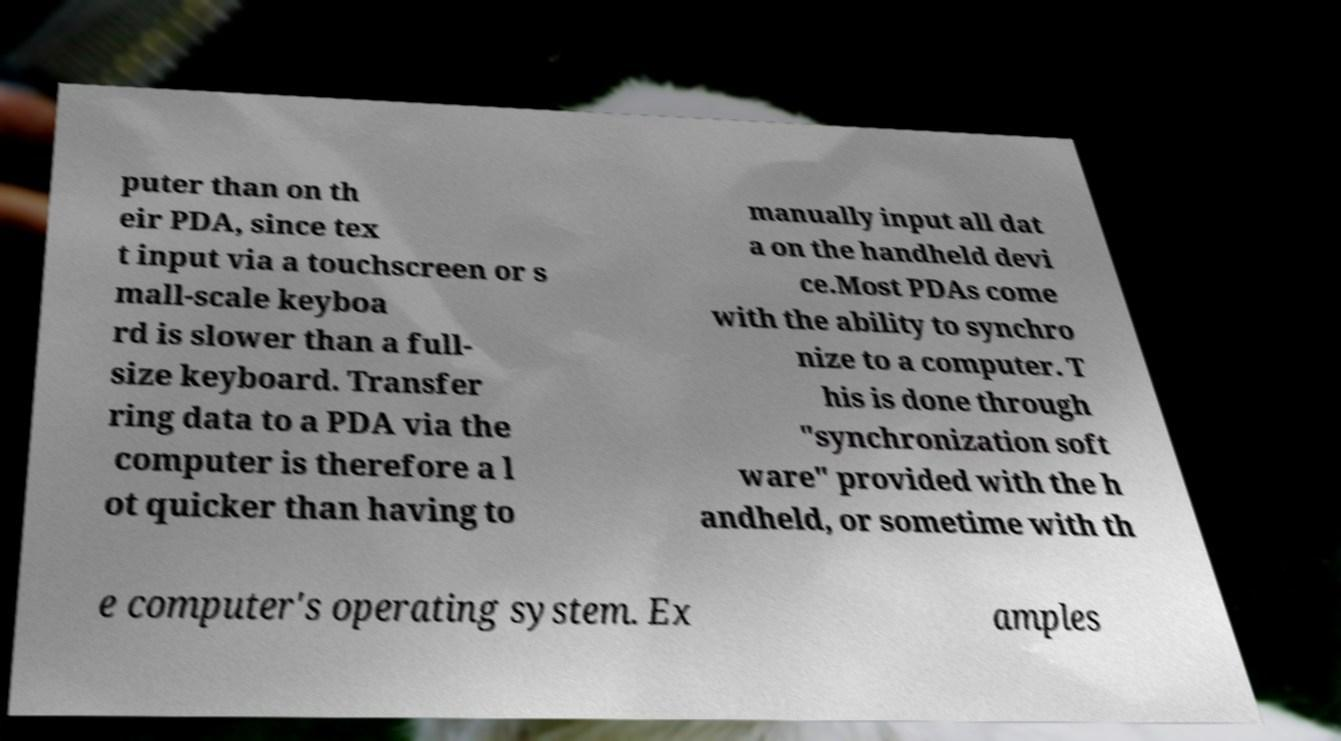There's text embedded in this image that I need extracted. Can you transcribe it verbatim? puter than on th eir PDA, since tex t input via a touchscreen or s mall-scale keyboa rd is slower than a full- size keyboard. Transfer ring data to a PDA via the computer is therefore a l ot quicker than having to manually input all dat a on the handheld devi ce.Most PDAs come with the ability to synchro nize to a computer. T his is done through "synchronization soft ware" provided with the h andheld, or sometime with th e computer's operating system. Ex amples 